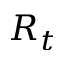Convert formula to latex. <formula><loc_0><loc_0><loc_500><loc_500>R _ { t }</formula> 